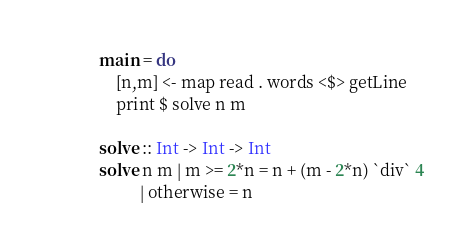Convert code to text. <code><loc_0><loc_0><loc_500><loc_500><_Haskell_>
main = do
    [n,m] <- map read . words <$> getLine
    print $ solve n m

solve :: Int -> Int -> Int
solve n m | m >= 2*n = n + (m - 2*n) `div` 4
          | otherwise = n
</code> 